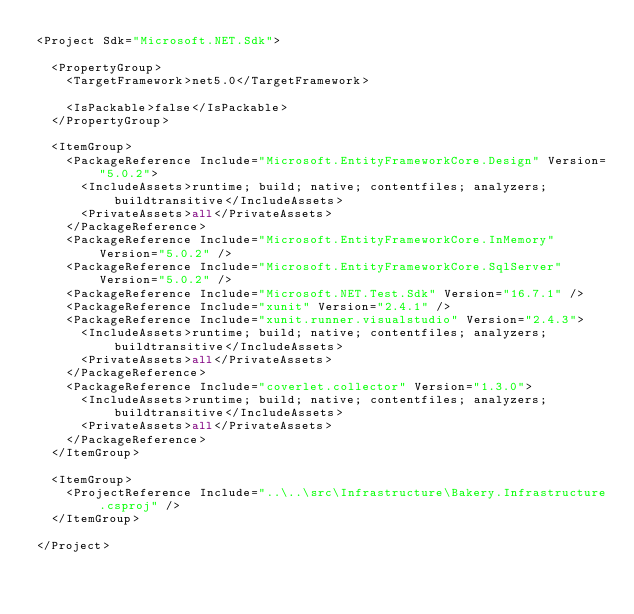Convert code to text. <code><loc_0><loc_0><loc_500><loc_500><_XML_><Project Sdk="Microsoft.NET.Sdk">

  <PropertyGroup>
    <TargetFramework>net5.0</TargetFramework>

    <IsPackable>false</IsPackable>
  </PropertyGroup>

  <ItemGroup>
    <PackageReference Include="Microsoft.EntityFrameworkCore.Design" Version="5.0.2">
      <IncludeAssets>runtime; build; native; contentfiles; analyzers; buildtransitive</IncludeAssets>
      <PrivateAssets>all</PrivateAssets>
    </PackageReference>
    <PackageReference Include="Microsoft.EntityFrameworkCore.InMemory" Version="5.0.2" />
    <PackageReference Include="Microsoft.EntityFrameworkCore.SqlServer" Version="5.0.2" />
    <PackageReference Include="Microsoft.NET.Test.Sdk" Version="16.7.1" />
    <PackageReference Include="xunit" Version="2.4.1" />
    <PackageReference Include="xunit.runner.visualstudio" Version="2.4.3">
      <IncludeAssets>runtime; build; native; contentfiles; analyzers; buildtransitive</IncludeAssets>
      <PrivateAssets>all</PrivateAssets>
    </PackageReference>
    <PackageReference Include="coverlet.collector" Version="1.3.0">
      <IncludeAssets>runtime; build; native; contentfiles; analyzers; buildtransitive</IncludeAssets>
      <PrivateAssets>all</PrivateAssets>
    </PackageReference>
  </ItemGroup>

  <ItemGroup>
    <ProjectReference Include="..\..\src\Infrastructure\Bakery.Infrastructure.csproj" />
  </ItemGroup>

</Project>
</code> 